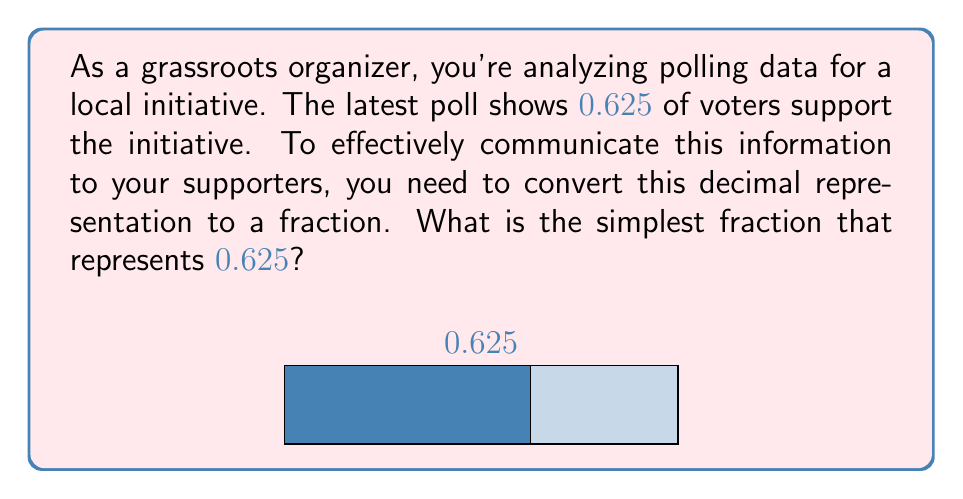Can you solve this math problem? To convert a decimal to a fraction, we follow these steps:

1) First, determine how many decimal places the number has. In this case, 0.625 has 3 decimal places.

2) Multiply both the numerator and denominator by 10^3 (1000) to move the decimal point:
   $$0.625 = \frac{0.625 * 1000}{1000} = \frac{625}{1000}$$

3) Now we have the fraction 625/1000. To simplify this, we need to find the greatest common divisor (GCD) of 625 and 1000.

4) We can use the Euclidean algorithm:
   1000 = 1 * 625 + 375
   625 = 1 * 375 + 250
   375 = 1 * 250 + 125
   250 = 2 * 125 + 0
   
   The GCD is 125.

5) Divide both the numerator and denominator by the GCD:
   $$\frac{625 \div 125}{1000 \div 125} = \frac{5}{8}$$

Therefore, 0.625 simplified to its lowest terms is 5/8.
Answer: $\frac{5}{8}$ 